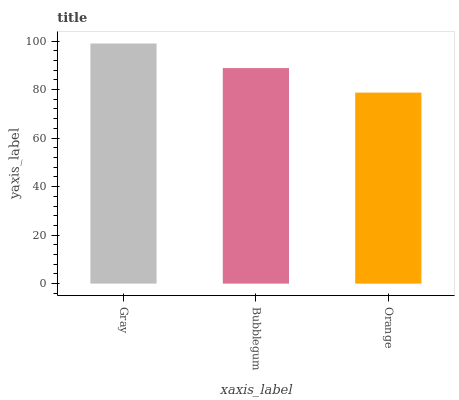Is Orange the minimum?
Answer yes or no. Yes. Is Gray the maximum?
Answer yes or no. Yes. Is Bubblegum the minimum?
Answer yes or no. No. Is Bubblegum the maximum?
Answer yes or no. No. Is Gray greater than Bubblegum?
Answer yes or no. Yes. Is Bubblegum less than Gray?
Answer yes or no. Yes. Is Bubblegum greater than Gray?
Answer yes or no. No. Is Gray less than Bubblegum?
Answer yes or no. No. Is Bubblegum the high median?
Answer yes or no. Yes. Is Bubblegum the low median?
Answer yes or no. Yes. Is Orange the high median?
Answer yes or no. No. Is Orange the low median?
Answer yes or no. No. 